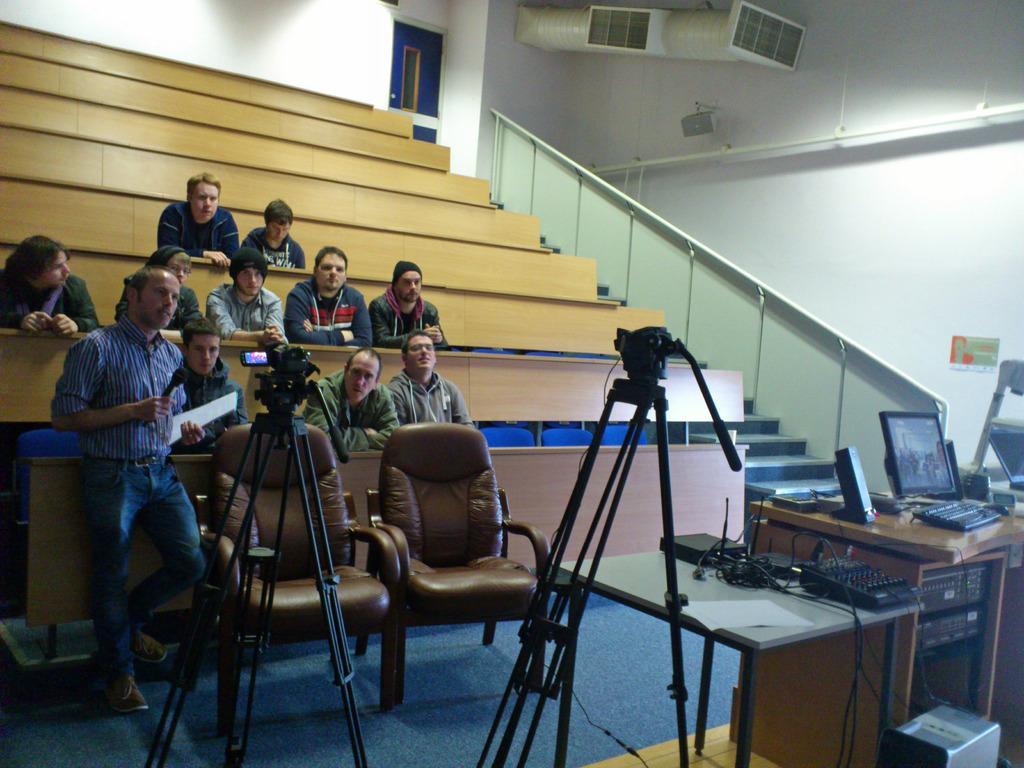Please provide a concise description of this image. The picture is taken inside an auditorium. There are people sitting on chair. There is a camera in the left a person is standing in front of the camera holding a mic and paper. He is talking something. On the right there is a table on that there are systems , monitor, keyboard. On the right there is a staircase. In the middle there is a door. 